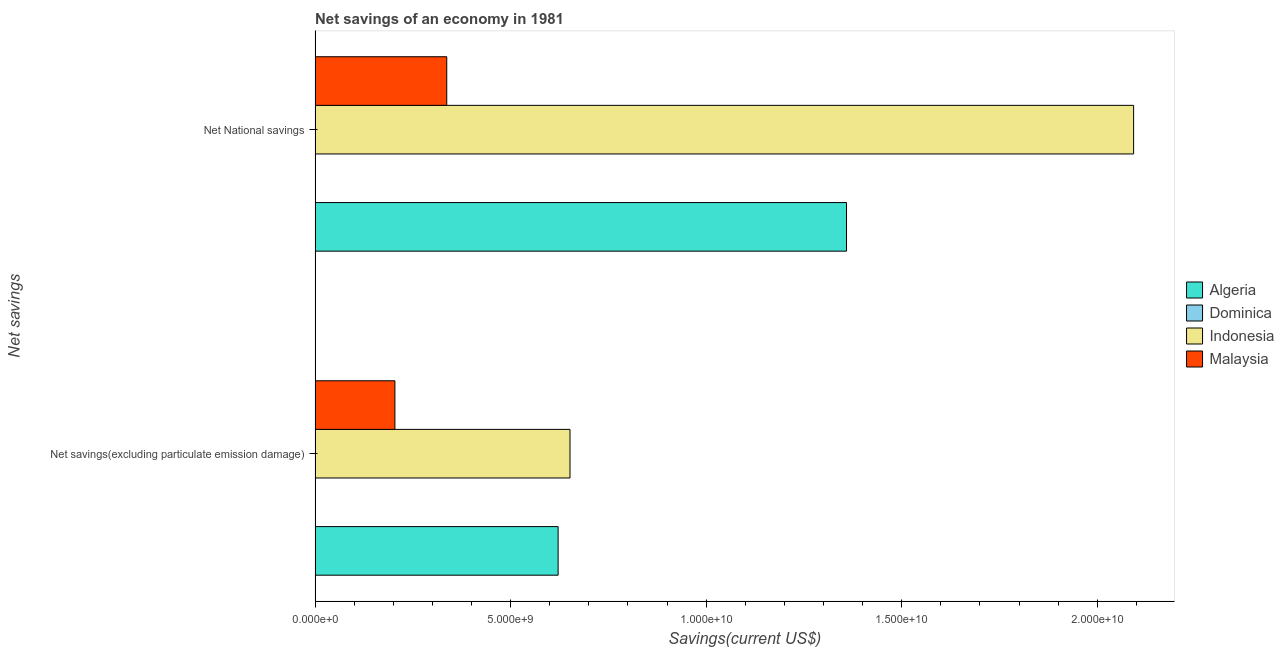Are the number of bars per tick equal to the number of legend labels?
Ensure brevity in your answer.  Yes. Are the number of bars on each tick of the Y-axis equal?
Make the answer very short. Yes. How many bars are there on the 1st tick from the top?
Provide a short and direct response. 4. How many bars are there on the 2nd tick from the bottom?
Make the answer very short. 4. What is the label of the 2nd group of bars from the top?
Provide a succinct answer. Net savings(excluding particulate emission damage). What is the net national savings in Algeria?
Offer a terse response. 1.36e+1. Across all countries, what is the maximum net savings(excluding particulate emission damage)?
Your answer should be very brief. 6.52e+09. Across all countries, what is the minimum net national savings?
Offer a terse response. 6.77e+06. In which country was the net savings(excluding particulate emission damage) minimum?
Your answer should be very brief. Dominica. What is the total net national savings in the graph?
Offer a very short reply. 3.79e+1. What is the difference between the net savings(excluding particulate emission damage) in Dominica and that in Malaysia?
Give a very brief answer. -2.03e+09. What is the difference between the net national savings in Dominica and the net savings(excluding particulate emission damage) in Algeria?
Your response must be concise. -6.21e+09. What is the average net national savings per country?
Offer a terse response. 9.47e+09. What is the difference between the net savings(excluding particulate emission damage) and net national savings in Dominica?
Give a very brief answer. 3.24e+06. In how many countries, is the net savings(excluding particulate emission damage) greater than 17000000000 US$?
Offer a very short reply. 0. What is the ratio of the net national savings in Malaysia to that in Algeria?
Your answer should be compact. 0.25. Is the net savings(excluding particulate emission damage) in Algeria less than that in Indonesia?
Offer a very short reply. Yes. What does the 4th bar from the top in Net National savings represents?
Ensure brevity in your answer.  Algeria. What does the 4th bar from the bottom in Net savings(excluding particulate emission damage) represents?
Provide a short and direct response. Malaysia. Are all the bars in the graph horizontal?
Keep it short and to the point. Yes. How many countries are there in the graph?
Your response must be concise. 4. What is the difference between two consecutive major ticks on the X-axis?
Your answer should be compact. 5.00e+09. Does the graph contain grids?
Make the answer very short. No. How many legend labels are there?
Give a very brief answer. 4. What is the title of the graph?
Make the answer very short. Net savings of an economy in 1981. Does "Tunisia" appear as one of the legend labels in the graph?
Your answer should be very brief. No. What is the label or title of the X-axis?
Keep it short and to the point. Savings(current US$). What is the label or title of the Y-axis?
Provide a succinct answer. Net savings. What is the Savings(current US$) in Algeria in Net savings(excluding particulate emission damage)?
Make the answer very short. 6.21e+09. What is the Savings(current US$) in Dominica in Net savings(excluding particulate emission damage)?
Provide a succinct answer. 1.00e+07. What is the Savings(current US$) in Indonesia in Net savings(excluding particulate emission damage)?
Give a very brief answer. 6.52e+09. What is the Savings(current US$) of Malaysia in Net savings(excluding particulate emission damage)?
Your answer should be very brief. 2.04e+09. What is the Savings(current US$) of Algeria in Net National savings?
Your answer should be compact. 1.36e+1. What is the Savings(current US$) of Dominica in Net National savings?
Make the answer very short. 6.77e+06. What is the Savings(current US$) of Indonesia in Net National savings?
Your response must be concise. 2.09e+1. What is the Savings(current US$) in Malaysia in Net National savings?
Give a very brief answer. 3.37e+09. Across all Net savings, what is the maximum Savings(current US$) of Algeria?
Give a very brief answer. 1.36e+1. Across all Net savings, what is the maximum Savings(current US$) of Dominica?
Offer a very short reply. 1.00e+07. Across all Net savings, what is the maximum Savings(current US$) of Indonesia?
Provide a succinct answer. 2.09e+1. Across all Net savings, what is the maximum Savings(current US$) in Malaysia?
Your answer should be very brief. 3.37e+09. Across all Net savings, what is the minimum Savings(current US$) in Algeria?
Offer a very short reply. 6.21e+09. Across all Net savings, what is the minimum Savings(current US$) in Dominica?
Ensure brevity in your answer.  6.77e+06. Across all Net savings, what is the minimum Savings(current US$) of Indonesia?
Give a very brief answer. 6.52e+09. Across all Net savings, what is the minimum Savings(current US$) of Malaysia?
Your answer should be very brief. 2.04e+09. What is the total Savings(current US$) of Algeria in the graph?
Your response must be concise. 1.98e+1. What is the total Savings(current US$) in Dominica in the graph?
Provide a succinct answer. 1.68e+07. What is the total Savings(current US$) in Indonesia in the graph?
Give a very brief answer. 2.74e+1. What is the total Savings(current US$) in Malaysia in the graph?
Make the answer very short. 5.41e+09. What is the difference between the Savings(current US$) of Algeria in Net savings(excluding particulate emission damage) and that in Net National savings?
Provide a short and direct response. -7.37e+09. What is the difference between the Savings(current US$) in Dominica in Net savings(excluding particulate emission damage) and that in Net National savings?
Give a very brief answer. 3.24e+06. What is the difference between the Savings(current US$) of Indonesia in Net savings(excluding particulate emission damage) and that in Net National savings?
Give a very brief answer. -1.44e+1. What is the difference between the Savings(current US$) in Malaysia in Net savings(excluding particulate emission damage) and that in Net National savings?
Keep it short and to the point. -1.33e+09. What is the difference between the Savings(current US$) of Algeria in Net savings(excluding particulate emission damage) and the Savings(current US$) of Dominica in Net National savings?
Offer a very short reply. 6.21e+09. What is the difference between the Savings(current US$) in Algeria in Net savings(excluding particulate emission damage) and the Savings(current US$) in Indonesia in Net National savings?
Your response must be concise. -1.47e+1. What is the difference between the Savings(current US$) of Algeria in Net savings(excluding particulate emission damage) and the Savings(current US$) of Malaysia in Net National savings?
Offer a terse response. 2.85e+09. What is the difference between the Savings(current US$) in Dominica in Net savings(excluding particulate emission damage) and the Savings(current US$) in Indonesia in Net National savings?
Give a very brief answer. -2.09e+1. What is the difference between the Savings(current US$) in Dominica in Net savings(excluding particulate emission damage) and the Savings(current US$) in Malaysia in Net National savings?
Provide a succinct answer. -3.36e+09. What is the difference between the Savings(current US$) in Indonesia in Net savings(excluding particulate emission damage) and the Savings(current US$) in Malaysia in Net National savings?
Provide a short and direct response. 3.15e+09. What is the average Savings(current US$) of Algeria per Net savings?
Give a very brief answer. 9.90e+09. What is the average Savings(current US$) in Dominica per Net savings?
Offer a very short reply. 8.39e+06. What is the average Savings(current US$) in Indonesia per Net savings?
Your answer should be compact. 1.37e+1. What is the average Savings(current US$) of Malaysia per Net savings?
Provide a succinct answer. 2.70e+09. What is the difference between the Savings(current US$) of Algeria and Savings(current US$) of Dominica in Net savings(excluding particulate emission damage)?
Ensure brevity in your answer.  6.20e+09. What is the difference between the Savings(current US$) in Algeria and Savings(current US$) in Indonesia in Net savings(excluding particulate emission damage)?
Your answer should be compact. -3.04e+08. What is the difference between the Savings(current US$) of Algeria and Savings(current US$) of Malaysia in Net savings(excluding particulate emission damage)?
Keep it short and to the point. 4.17e+09. What is the difference between the Savings(current US$) in Dominica and Savings(current US$) in Indonesia in Net savings(excluding particulate emission damage)?
Make the answer very short. -6.51e+09. What is the difference between the Savings(current US$) in Dominica and Savings(current US$) in Malaysia in Net savings(excluding particulate emission damage)?
Give a very brief answer. -2.03e+09. What is the difference between the Savings(current US$) in Indonesia and Savings(current US$) in Malaysia in Net savings(excluding particulate emission damage)?
Make the answer very short. 4.48e+09. What is the difference between the Savings(current US$) in Algeria and Savings(current US$) in Dominica in Net National savings?
Your answer should be very brief. 1.36e+1. What is the difference between the Savings(current US$) of Algeria and Savings(current US$) of Indonesia in Net National savings?
Your answer should be compact. -7.34e+09. What is the difference between the Savings(current US$) of Algeria and Savings(current US$) of Malaysia in Net National savings?
Give a very brief answer. 1.02e+1. What is the difference between the Savings(current US$) of Dominica and Savings(current US$) of Indonesia in Net National savings?
Your answer should be compact. -2.09e+1. What is the difference between the Savings(current US$) of Dominica and Savings(current US$) of Malaysia in Net National savings?
Make the answer very short. -3.36e+09. What is the difference between the Savings(current US$) in Indonesia and Savings(current US$) in Malaysia in Net National savings?
Your response must be concise. 1.76e+1. What is the ratio of the Savings(current US$) in Algeria in Net savings(excluding particulate emission damage) to that in Net National savings?
Your answer should be compact. 0.46. What is the ratio of the Savings(current US$) in Dominica in Net savings(excluding particulate emission damage) to that in Net National savings?
Keep it short and to the point. 1.48. What is the ratio of the Savings(current US$) of Indonesia in Net savings(excluding particulate emission damage) to that in Net National savings?
Ensure brevity in your answer.  0.31. What is the ratio of the Savings(current US$) in Malaysia in Net savings(excluding particulate emission damage) to that in Net National savings?
Your answer should be compact. 0.61. What is the difference between the highest and the second highest Savings(current US$) in Algeria?
Make the answer very short. 7.37e+09. What is the difference between the highest and the second highest Savings(current US$) of Dominica?
Your response must be concise. 3.24e+06. What is the difference between the highest and the second highest Savings(current US$) of Indonesia?
Ensure brevity in your answer.  1.44e+1. What is the difference between the highest and the second highest Savings(current US$) of Malaysia?
Give a very brief answer. 1.33e+09. What is the difference between the highest and the lowest Savings(current US$) in Algeria?
Offer a very short reply. 7.37e+09. What is the difference between the highest and the lowest Savings(current US$) of Dominica?
Provide a succinct answer. 3.24e+06. What is the difference between the highest and the lowest Savings(current US$) in Indonesia?
Offer a terse response. 1.44e+1. What is the difference between the highest and the lowest Savings(current US$) of Malaysia?
Ensure brevity in your answer.  1.33e+09. 